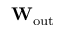Convert formula to latex. <formula><loc_0><loc_0><loc_500><loc_500>W _ { o u t }</formula> 